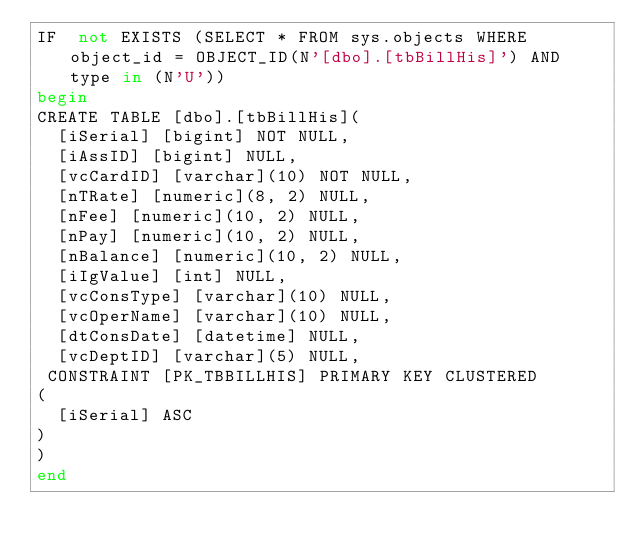Convert code to text. <code><loc_0><loc_0><loc_500><loc_500><_SQL_>IF  not EXISTS (SELECT * FROM sys.objects WHERE object_id = OBJECT_ID(N'[dbo].[tbBillHis]') AND type in (N'U'))
begin
CREATE TABLE [dbo].[tbBillHis](
	[iSerial] [bigint] NOT NULL,
	[iAssID] [bigint] NULL,
	[vcCardID] [varchar](10) NOT NULL,
	[nTRate] [numeric](8, 2) NULL,
	[nFee] [numeric](10, 2) NULL,
	[nPay] [numeric](10, 2) NULL,
	[nBalance] [numeric](10, 2) NULL,
	[iIgValue] [int] NULL,
	[vcConsType] [varchar](10) NULL,
	[vcOperName] [varchar](10) NULL,
	[dtConsDate] [datetime] NULL,
	[vcDeptID] [varchar](5) NULL,
 CONSTRAINT [PK_TBBILLHIS] PRIMARY KEY CLUSTERED 
(
	[iSerial] ASC
)
)
end

</code> 